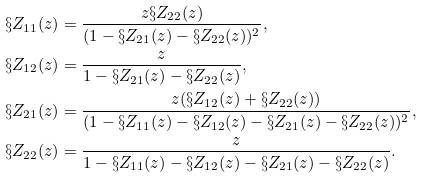Convert formula to latex. <formula><loc_0><loc_0><loc_500><loc_500>\S Z _ { 1 1 } ( z ) & = \frac { z \S Z _ { 2 2 } ( z ) } { ( 1 - \S Z _ { 2 1 } ( z ) - \S Z _ { 2 2 } ( z ) ) ^ { 2 } } , \\ \S Z _ { 1 2 } ( z ) & = \frac { z } { 1 - \S Z _ { 2 1 } ( z ) - \S Z _ { 2 2 } ( z ) } , \\ \S Z _ { 2 1 } ( z ) & = \frac { z ( \S Z _ { 1 2 } ( z ) + \S Z _ { 2 2 } ( z ) ) } { ( 1 - \S Z _ { 1 1 } ( z ) - \S Z _ { 1 2 } ( z ) - \S Z _ { 2 1 } ( z ) - \S Z _ { 2 2 } ( z ) ) ^ { 2 } } , \\ \S Z _ { 2 2 } ( z ) & = \frac { z } { 1 - \S Z _ { 1 1 } ( z ) - \S Z _ { 1 2 } ( z ) - \S Z _ { 2 1 } ( z ) - \S Z _ { 2 2 } ( z ) } .</formula> 